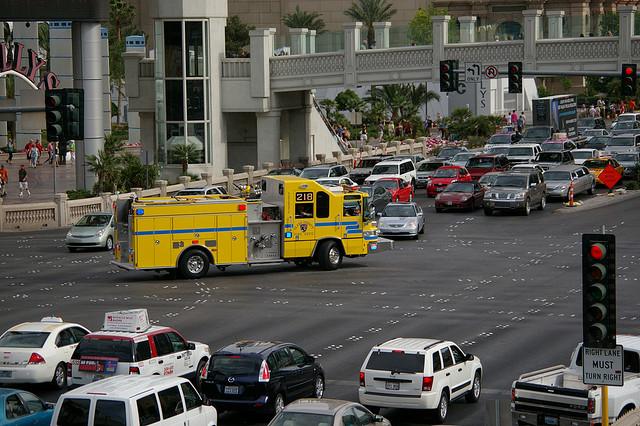How many vehicles are in this picture?
Answer briefly. 30. Why do the cars need to yield to the yellow vehicle in the center?
Keep it brief. Fire truck. Is this a toy fire truck?
Answer briefly. No. Is that a fire truck?
Give a very brief answer. Yes. Is there a lot of traffic?
Short answer required. Yes. What are the yellow vehicles used for?
Answer briefly. Fighting fires. 